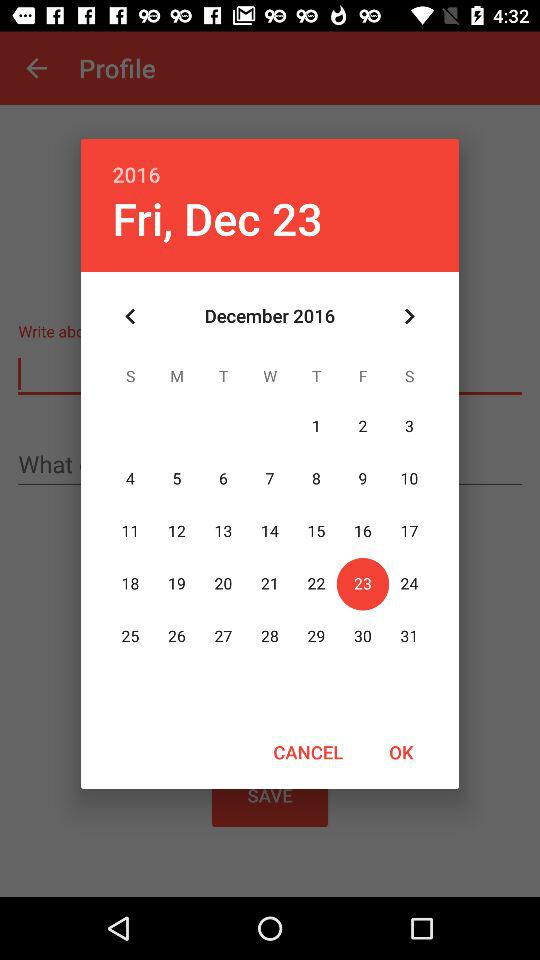What is the date? The date is Friday, December 23, 2016. 